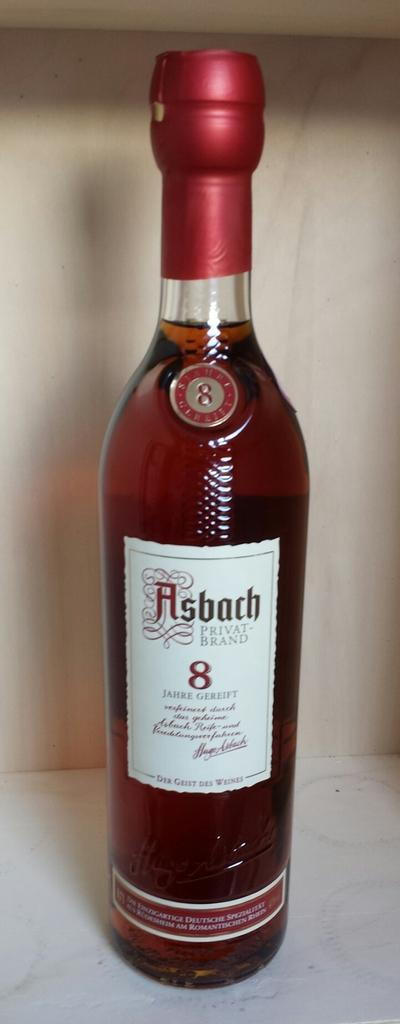<image>
Provide a brief description of the given image. A maroon tinted, glass bottle of Asbach Privat-Brand liquor. 